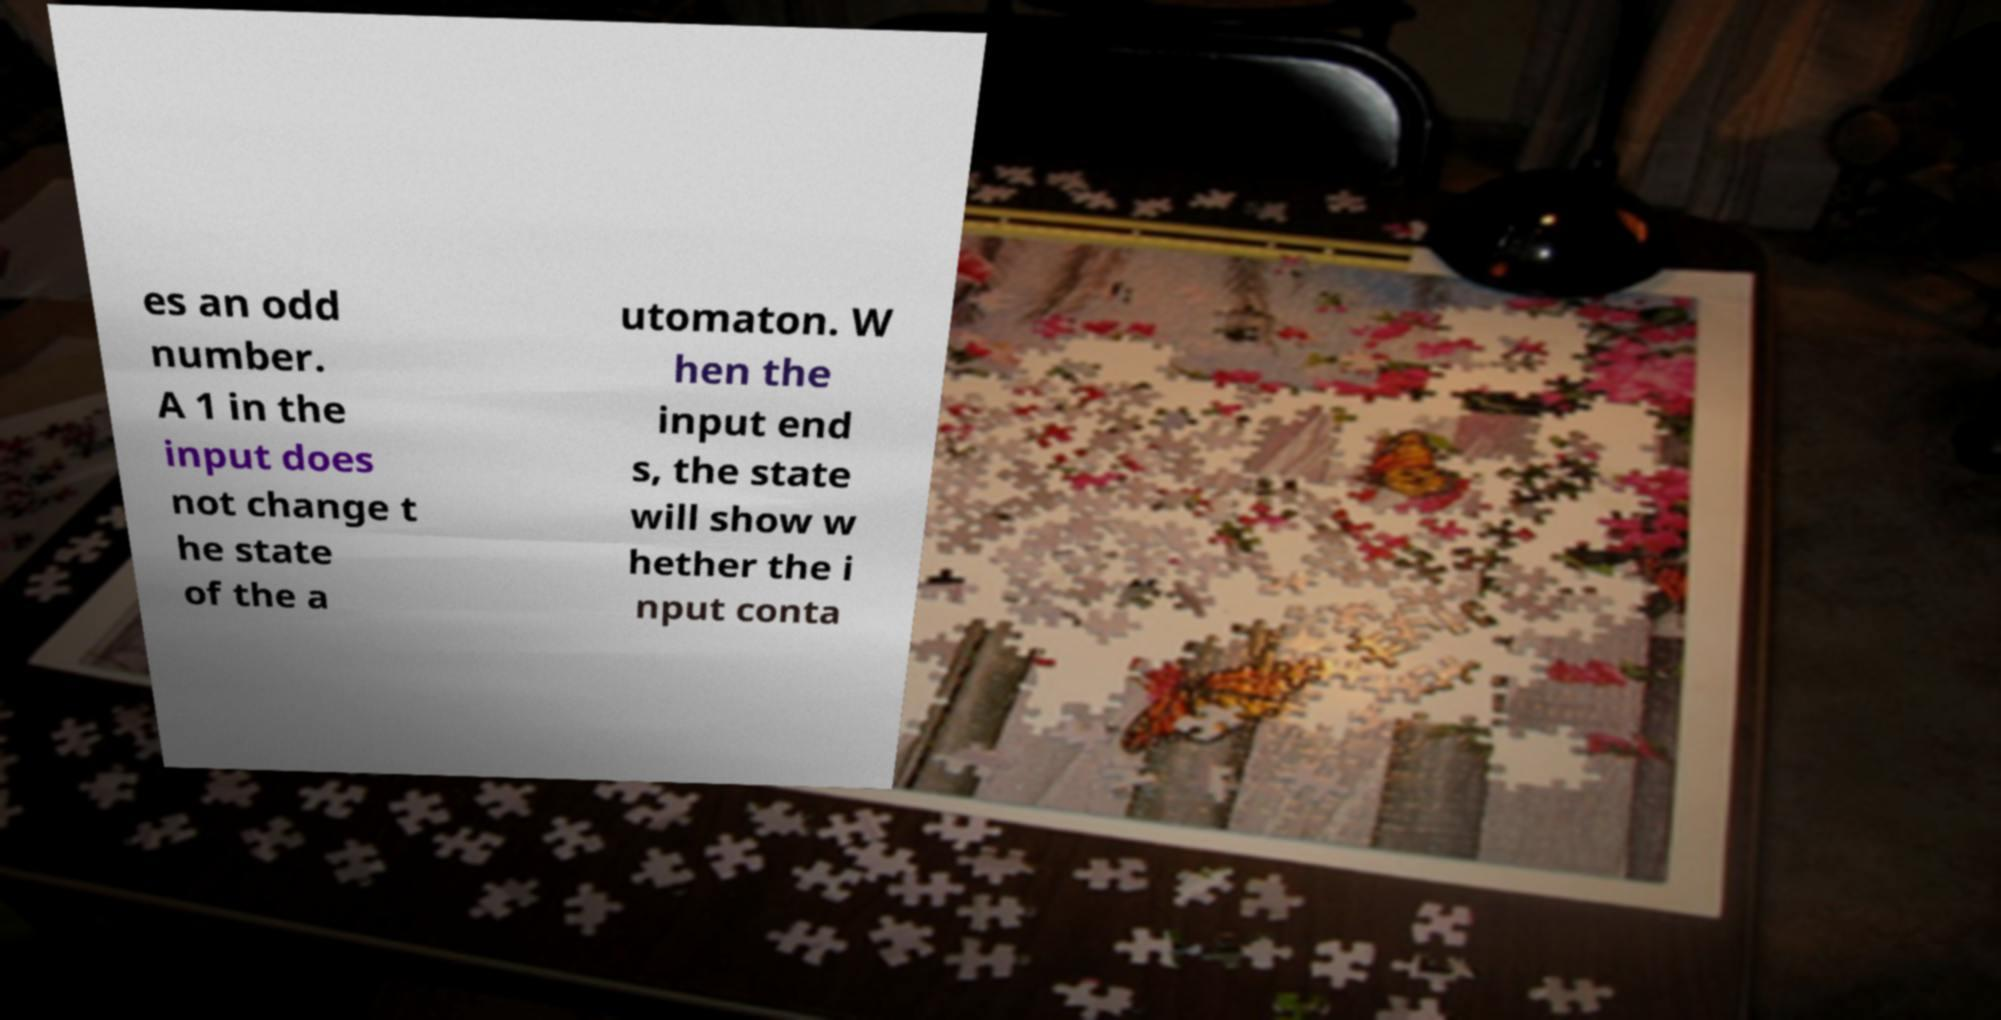What messages or text are displayed in this image? I need them in a readable, typed format. es an odd number. A 1 in the input does not change t he state of the a utomaton. W hen the input end s, the state will show w hether the i nput conta 